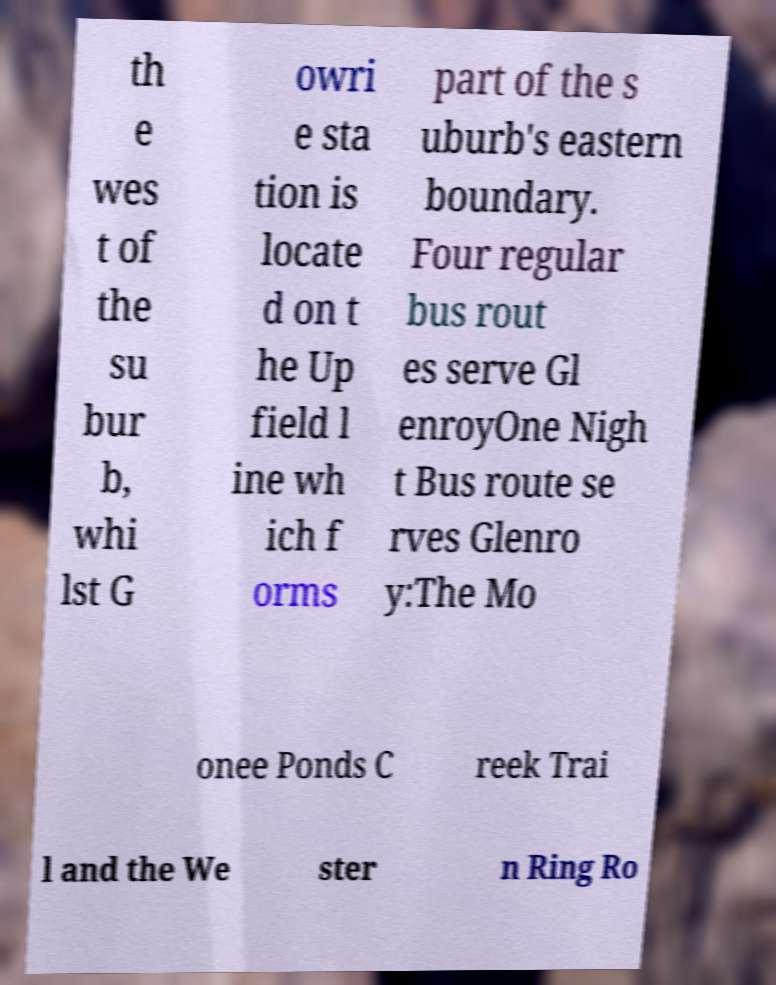I need the written content from this picture converted into text. Can you do that? th e wes t of the su bur b, whi lst G owri e sta tion is locate d on t he Up field l ine wh ich f orms part of the s uburb's eastern boundary. Four regular bus rout es serve Gl enroyOne Nigh t Bus route se rves Glenro y:The Mo onee Ponds C reek Trai l and the We ster n Ring Ro 